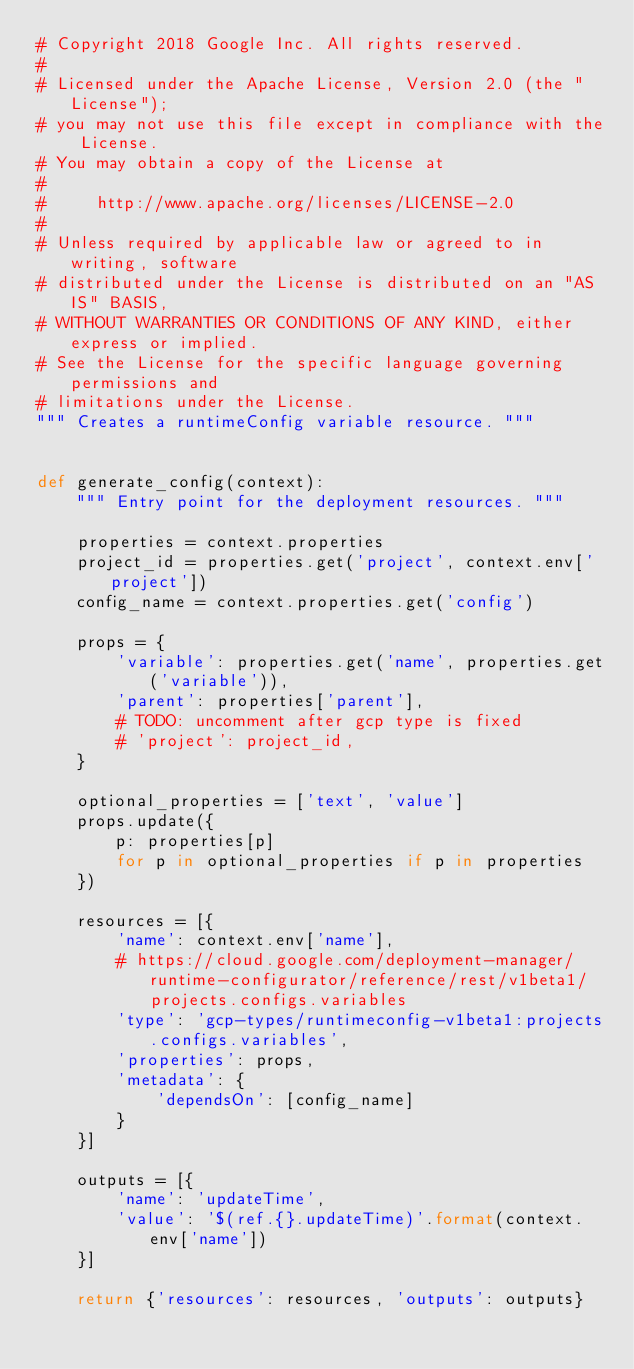Convert code to text. <code><loc_0><loc_0><loc_500><loc_500><_Python_># Copyright 2018 Google Inc. All rights reserved.
#
# Licensed under the Apache License, Version 2.0 (the "License");
# you may not use this file except in compliance with the License.
# You may obtain a copy of the License at
#
#     http://www.apache.org/licenses/LICENSE-2.0
#
# Unless required by applicable law or agreed to in writing, software
# distributed under the License is distributed on an "AS IS" BASIS,
# WITHOUT WARRANTIES OR CONDITIONS OF ANY KIND, either express or implied.
# See the License for the specific language governing permissions and
# limitations under the License.
""" Creates a runtimeConfig variable resource. """


def generate_config(context):
    """ Entry point for the deployment resources. """

    properties = context.properties
    project_id = properties.get('project', context.env['project'])
    config_name = context.properties.get('config')

    props = {
        'variable': properties.get('name', properties.get('variable')),
        'parent': properties['parent'],
        # TODO: uncomment after gcp type is fixed
        # 'project': project_id,
    }

    optional_properties = ['text', 'value']
    props.update({
        p: properties[p]
        for p in optional_properties if p in properties
    })

    resources = [{
        'name': context.env['name'],
        # https://cloud.google.com/deployment-manager/runtime-configurator/reference/rest/v1beta1/projects.configs.variables
        'type': 'gcp-types/runtimeconfig-v1beta1:projects.configs.variables',
        'properties': props,
        'metadata': {
            'dependsOn': [config_name]
        }
    }]

    outputs = [{
        'name': 'updateTime',
        'value': '$(ref.{}.updateTime)'.format(context.env['name'])
    }]

    return {'resources': resources, 'outputs': outputs}
</code> 